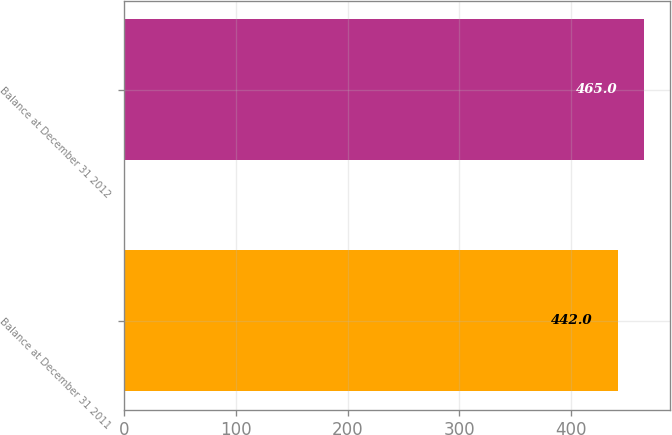Convert chart to OTSL. <chart><loc_0><loc_0><loc_500><loc_500><bar_chart><fcel>Balance at December 31 2011<fcel>Balance at December 31 2012<nl><fcel>442<fcel>465<nl></chart> 